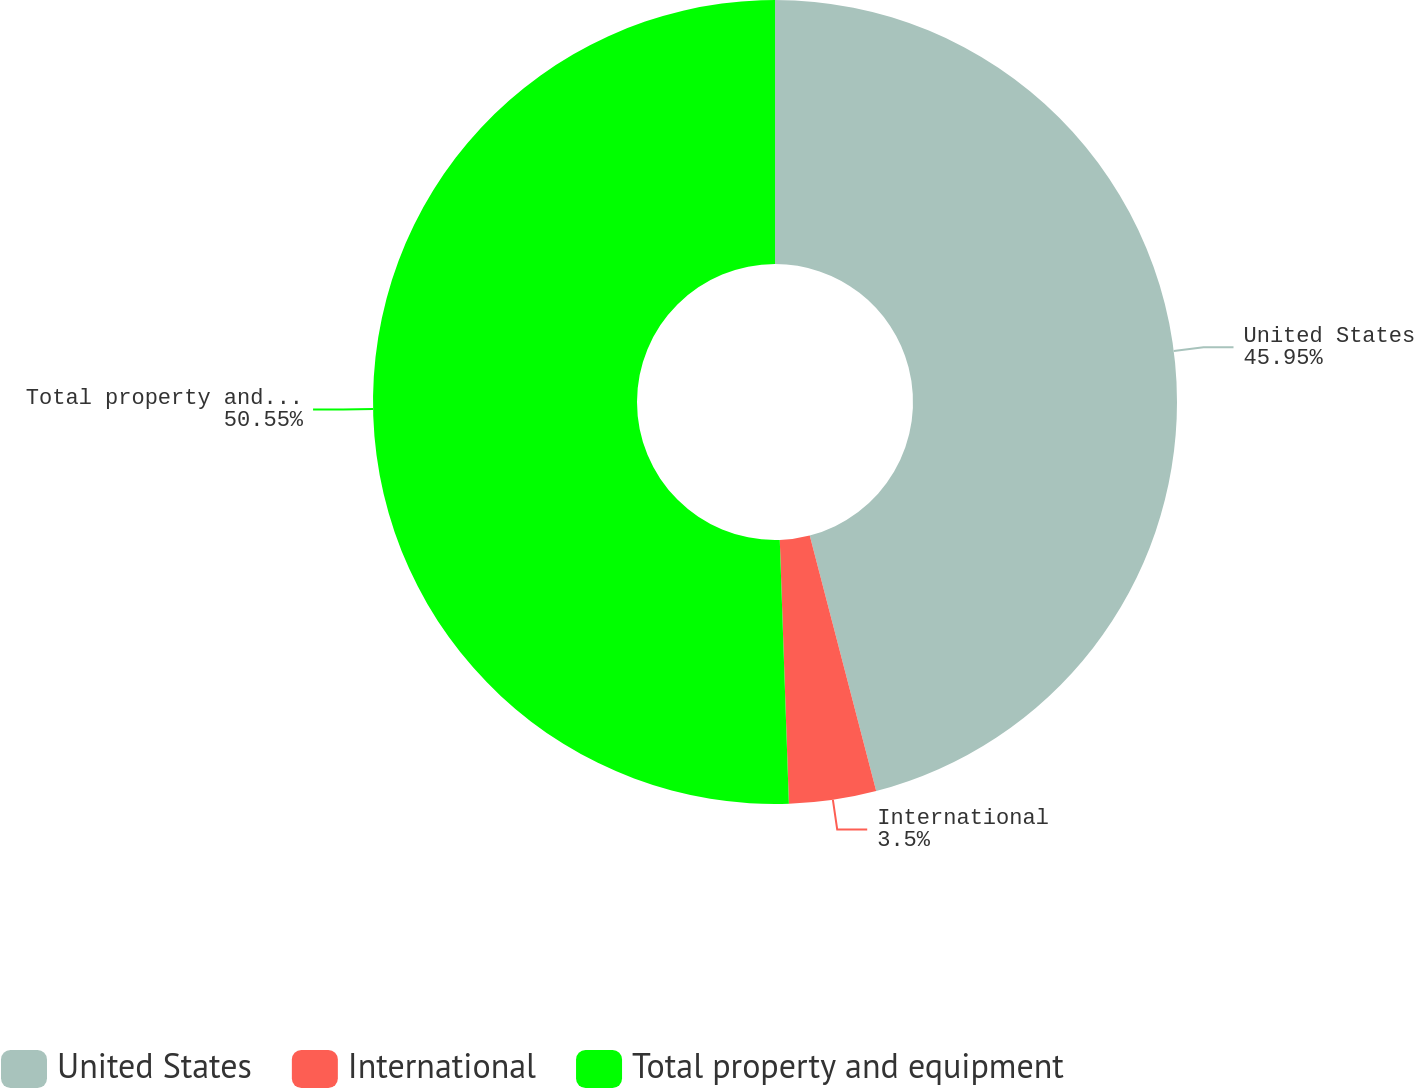<chart> <loc_0><loc_0><loc_500><loc_500><pie_chart><fcel>United States<fcel>International<fcel>Total property and equipment<nl><fcel>45.95%<fcel>3.5%<fcel>50.55%<nl></chart> 